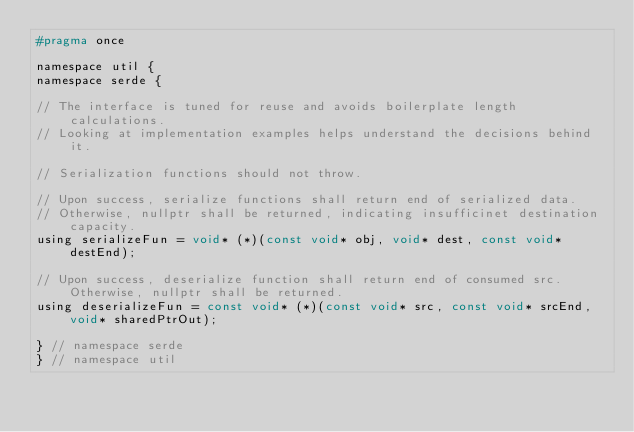<code> <loc_0><loc_0><loc_500><loc_500><_C_>#pragma once

namespace util {
namespace serde {

// The interface is tuned for reuse and avoids boilerplate length calculations.
// Looking at implementation examples helps understand the decisions behind it.

// Serialization functions should not throw.

// Upon success, serialize functions shall return end of serialized data.
// Otherwise, nullptr shall be returned, indicating insufficinet destination capacity.
using serializeFun = void* (*)(const void* obj, void* dest, const void* destEnd);

// Upon success, deserialize function shall return end of consumed src. Otherwise, nullptr shall be returned.
using deserializeFun = const void* (*)(const void* src, const void* srcEnd, void* sharedPtrOut);

} // namespace serde
} // namespace util
</code> 